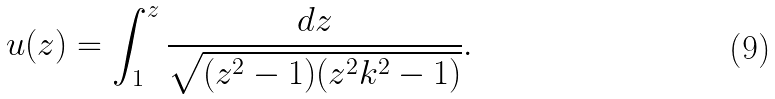Convert formula to latex. <formula><loc_0><loc_0><loc_500><loc_500>u ( z ) = \int _ { 1 } ^ { z } \frac { d z } { \sqrt { ( z ^ { 2 } - 1 ) ( z ^ { 2 } k ^ { 2 } - 1 ) } } .</formula> 